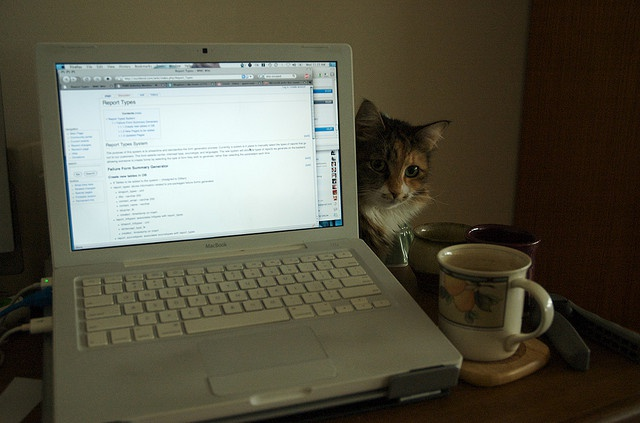Describe the objects in this image and their specific colors. I can see laptop in black, gray, white, and darkgreen tones, cup in black, darkgreen, and olive tones, cat in black and olive tones, cup in black, darkgreen, and gray tones, and cup in black, olive, and gray tones in this image. 